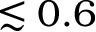Convert formula to latex. <formula><loc_0><loc_0><loc_500><loc_500>\lesssim 0 . 6</formula> 